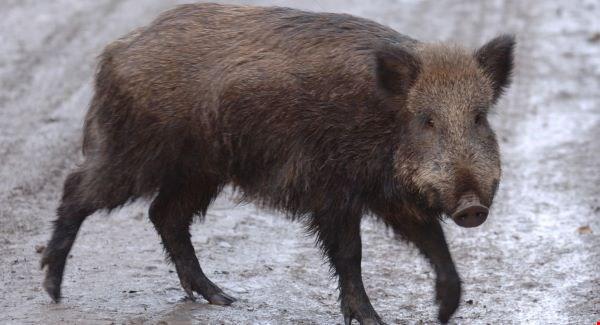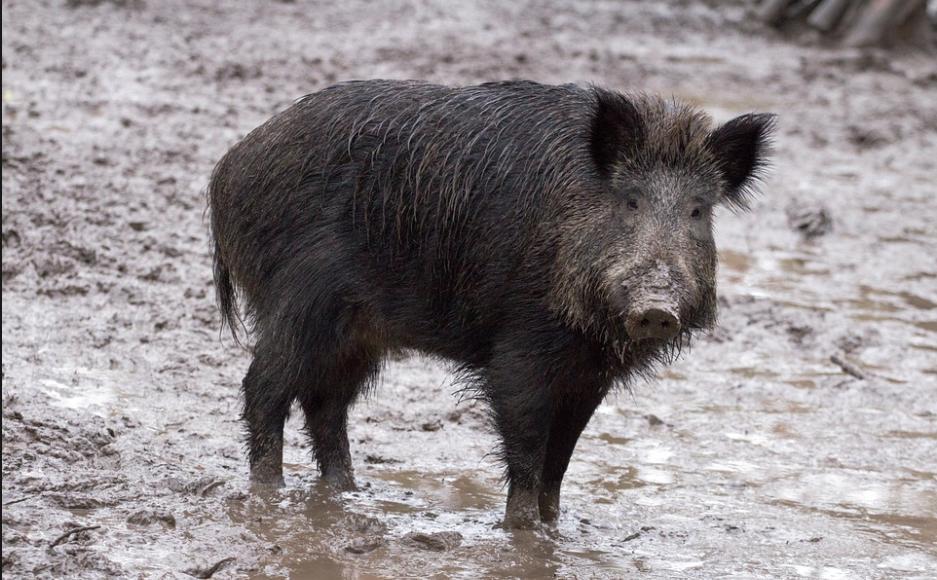The first image is the image on the left, the second image is the image on the right. For the images shown, is this caption "there is exactly one boar in the image on the right" true? Answer yes or no. Yes. The first image is the image on the left, the second image is the image on the right. Analyze the images presented: Is the assertion "At least one of the images shows exactly one boar." valid? Answer yes or no. Yes. 